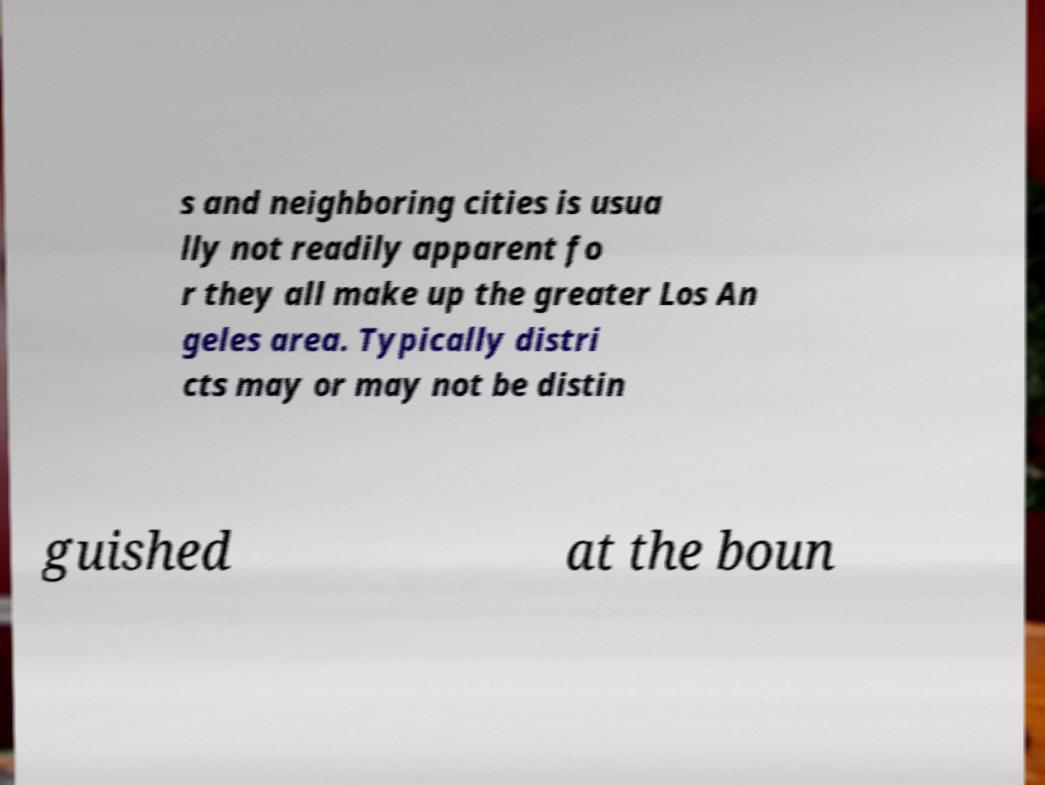Could you extract and type out the text from this image? s and neighboring cities is usua lly not readily apparent fo r they all make up the greater Los An geles area. Typically distri cts may or may not be distin guished at the boun 